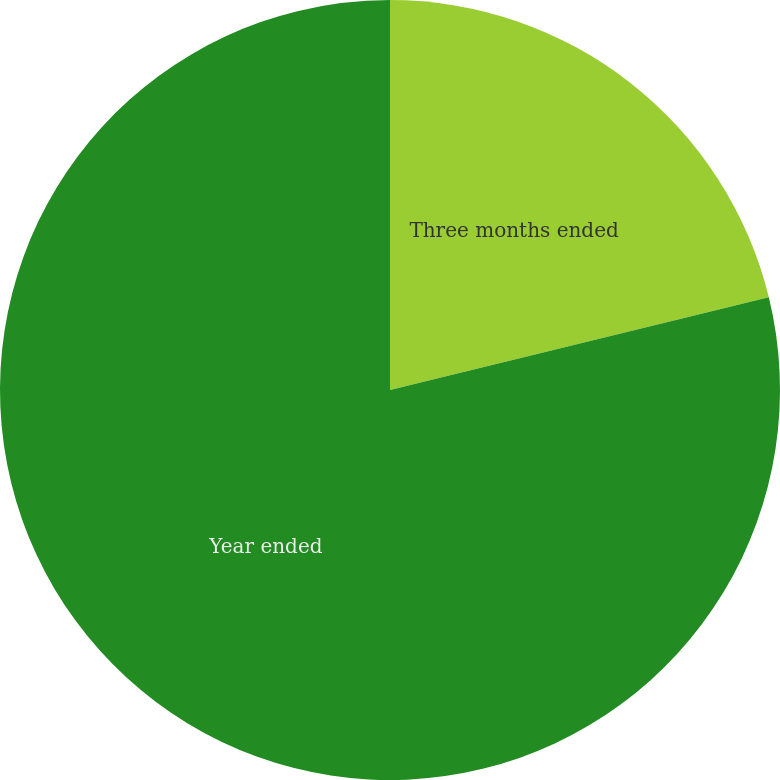Convert chart. <chart><loc_0><loc_0><loc_500><loc_500><pie_chart><fcel>Three months ended<fcel>Year ended<nl><fcel>21.18%<fcel>78.82%<nl></chart> 